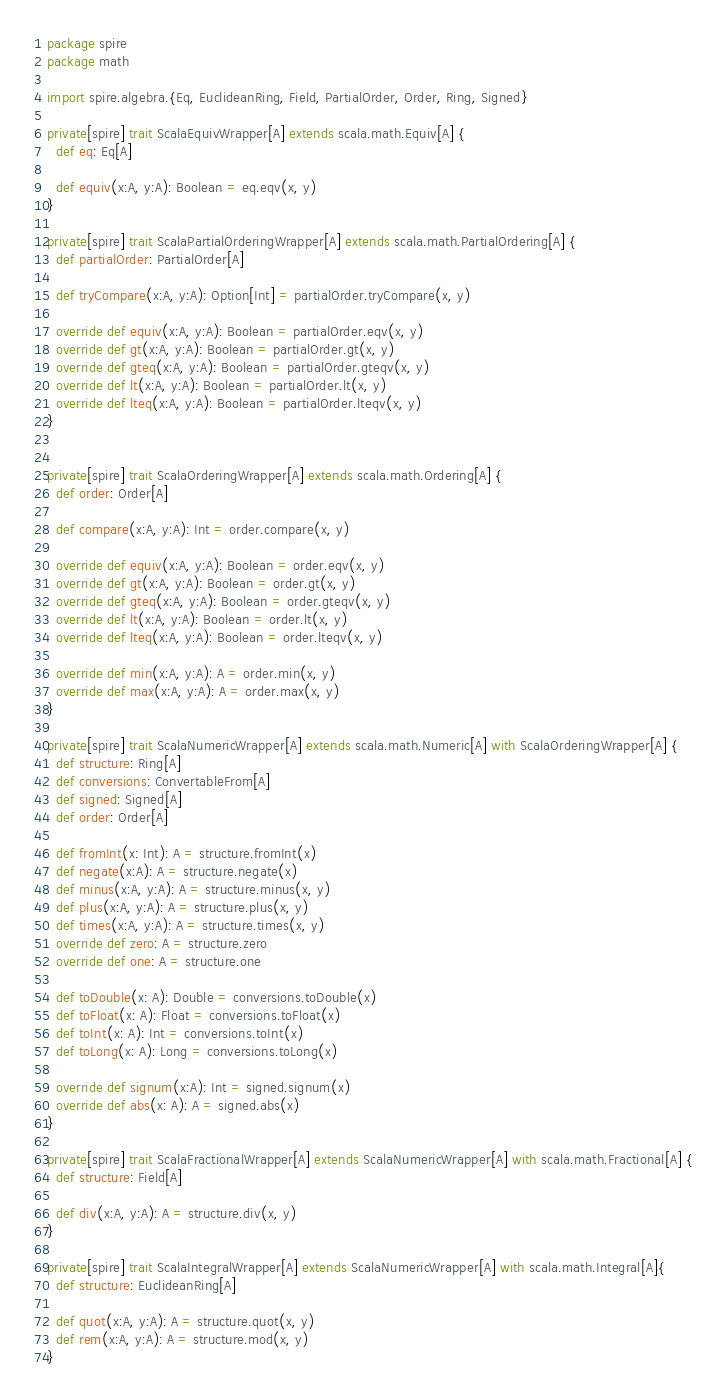Convert code to text. <code><loc_0><loc_0><loc_500><loc_500><_Scala_>package spire
package math

import spire.algebra.{Eq, EuclideanRing, Field, PartialOrder, Order, Ring, Signed}

private[spire] trait ScalaEquivWrapper[A] extends scala.math.Equiv[A] {
  def eq: Eq[A]

  def equiv(x:A, y:A): Boolean = eq.eqv(x, y)
}

private[spire] trait ScalaPartialOrderingWrapper[A] extends scala.math.PartialOrdering[A] {
  def partialOrder: PartialOrder[A]

  def tryCompare(x:A, y:A): Option[Int] = partialOrder.tryCompare(x, y)

  override def equiv(x:A, y:A): Boolean = partialOrder.eqv(x, y)
  override def gt(x:A, y:A): Boolean = partialOrder.gt(x, y)
  override def gteq(x:A, y:A): Boolean = partialOrder.gteqv(x, y)
  override def lt(x:A, y:A): Boolean = partialOrder.lt(x, y)
  override def lteq(x:A, y:A): Boolean = partialOrder.lteqv(x, y)
}


private[spire] trait ScalaOrderingWrapper[A] extends scala.math.Ordering[A] {
  def order: Order[A]

  def compare(x:A, y:A): Int = order.compare(x, y)

  override def equiv(x:A, y:A): Boolean = order.eqv(x, y)
  override def gt(x:A, y:A): Boolean = order.gt(x, y)
  override def gteq(x:A, y:A): Boolean = order.gteqv(x, y)
  override def lt(x:A, y:A): Boolean = order.lt(x, y)
  override def lteq(x:A, y:A): Boolean = order.lteqv(x, y)

  override def min(x:A, y:A): A = order.min(x, y)
  override def max(x:A, y:A): A = order.max(x, y)
}

private[spire] trait ScalaNumericWrapper[A] extends scala.math.Numeric[A] with ScalaOrderingWrapper[A] {
  def structure: Ring[A]
  def conversions: ConvertableFrom[A]
  def signed: Signed[A]
  def order: Order[A]

  def fromInt(x: Int): A = structure.fromInt(x)
  def negate(x:A): A = structure.negate(x)
  def minus(x:A, y:A): A = structure.minus(x, y)
  def plus(x:A, y:A): A = structure.plus(x, y)
  def times(x:A, y:A): A = structure.times(x, y)
  override def zero: A = structure.zero
  override def one: A = structure.one

  def toDouble(x: A): Double = conversions.toDouble(x)
  def toFloat(x: A): Float = conversions.toFloat(x)
  def toInt(x: A): Int = conversions.toInt(x)
  def toLong(x: A): Long = conversions.toLong(x)

  override def signum(x:A): Int = signed.signum(x)
  override def abs(x: A): A = signed.abs(x)
}

private[spire] trait ScalaFractionalWrapper[A] extends ScalaNumericWrapper[A] with scala.math.Fractional[A] {
  def structure: Field[A]

  def div(x:A, y:A): A = structure.div(x, y)
}

private[spire] trait ScalaIntegralWrapper[A] extends ScalaNumericWrapper[A] with scala.math.Integral[A]{
  def structure: EuclideanRing[A]

  def quot(x:A, y:A): A = structure.quot(x, y)
  def rem(x:A, y:A): A = structure.mod(x, y)
}
</code> 